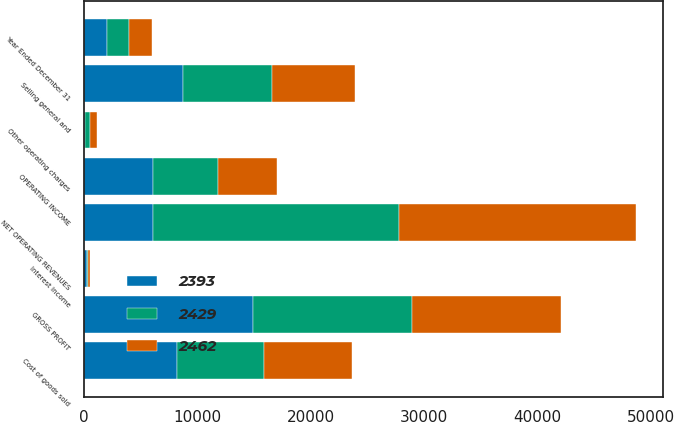Convert chart to OTSL. <chart><loc_0><loc_0><loc_500><loc_500><stacked_bar_chart><ecel><fcel>Year Ended December 31<fcel>NET OPERATING REVENUES<fcel>Cost of goods sold<fcel>GROSS PROFIT<fcel>Selling general and<fcel>Other operating charges<fcel>OPERATING INCOME<fcel>Interest income<nl><fcel>2393<fcel>2005<fcel>6085<fcel>8195<fcel>14909<fcel>8739<fcel>85<fcel>6085<fcel>235<nl><fcel>2429<fcel>2004<fcel>21742<fcel>7674<fcel>14068<fcel>7890<fcel>480<fcel>5698<fcel>157<nl><fcel>2462<fcel>2003<fcel>20857<fcel>7776<fcel>13081<fcel>7287<fcel>573<fcel>5221<fcel>176<nl></chart> 